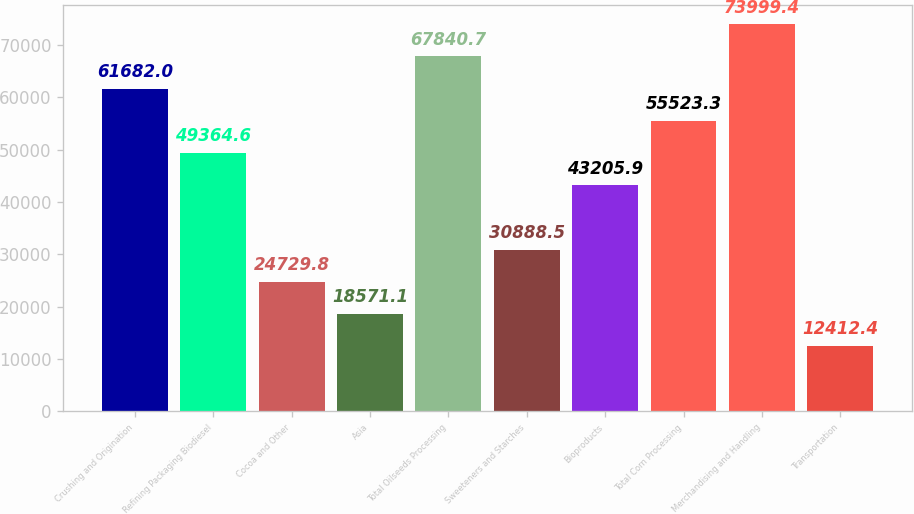Convert chart. <chart><loc_0><loc_0><loc_500><loc_500><bar_chart><fcel>Crushing and Origination<fcel>Refining Packaging Biodiesel<fcel>Cocoa and Other<fcel>Asia<fcel>Total Oilseeds Processing<fcel>Sweeteners and Starches<fcel>Bioproducts<fcel>Total Corn Processing<fcel>Merchandising and Handling<fcel>Transportation<nl><fcel>61682<fcel>49364.6<fcel>24729.8<fcel>18571.1<fcel>67840.7<fcel>30888.5<fcel>43205.9<fcel>55523.3<fcel>73999.4<fcel>12412.4<nl></chart> 